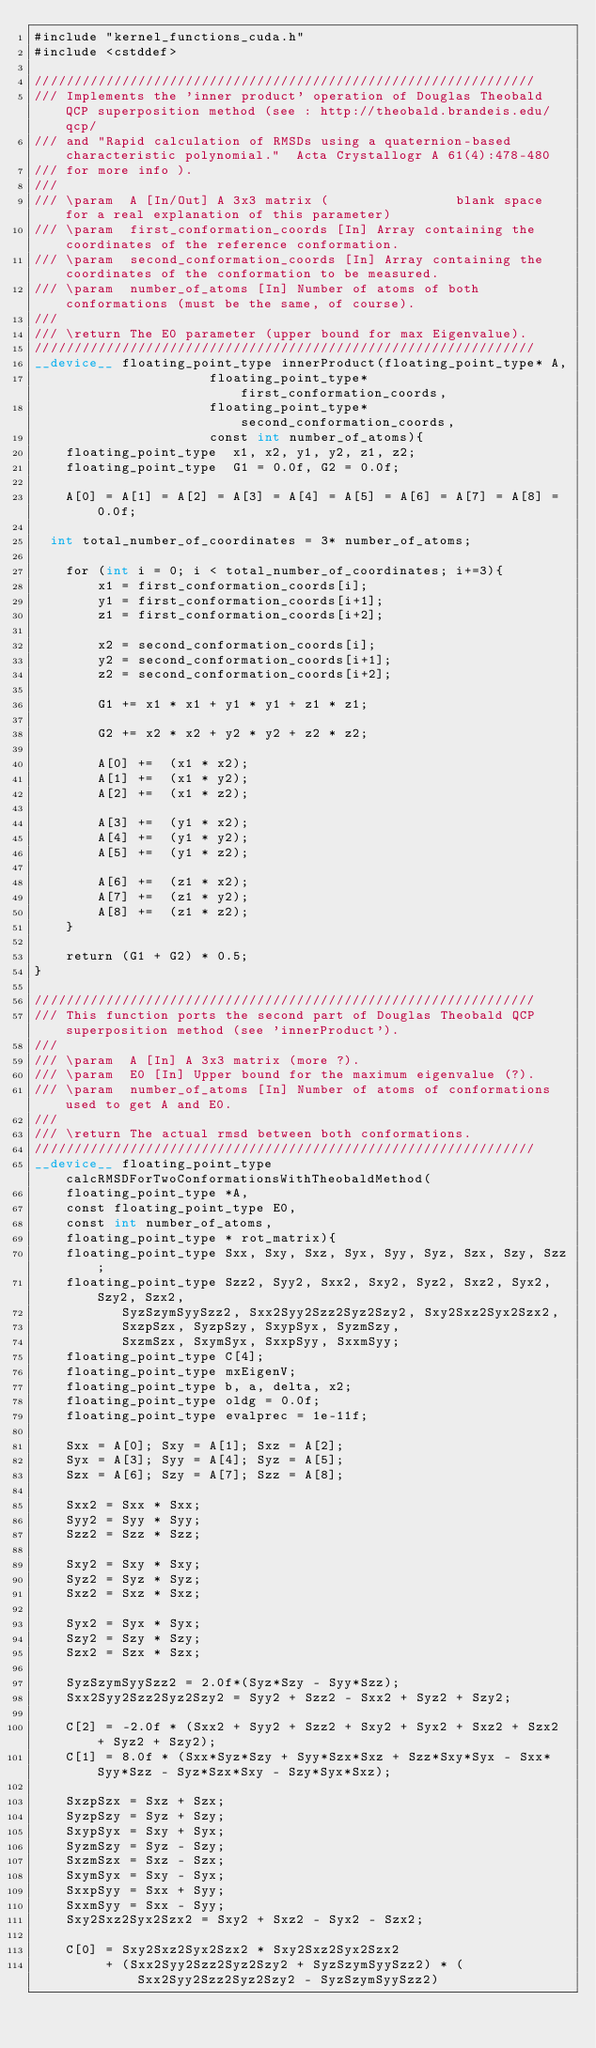<code> <loc_0><loc_0><loc_500><loc_500><_Cuda_>#include "kernel_functions_cuda.h"
#include <cstddef>

///////////////////////////////////////////////////////////////
/// Implements the 'inner product' operation of Douglas Theobald QCP superposition method (see : http://theobald.brandeis.edu/qcp/
/// and "Rapid calculation of RMSDs using a quaternion-based characteristic polynomial."  Acta Crystallogr A 61(4):478-480
/// for more info ).
///
/// \param 	A [In/Out] A 3x3 matrix (                blank space for a real explanation of this parameter)
/// \param 	first_conformation_coords [In] Array containing the coordinates of the reference conformation.
/// \param 	second_conformation_coords [In] Array containing the coordinates of the conformation to be measured.
/// \param 	number_of_atoms [In] Number of atoms of both conformations (must be the same, of course).
///
/// \return The E0 parameter (upper bound for max Eigenvalue).
///////////////////////////////////////////////////////////////
__device__ floating_point_type innerProduct(floating_point_type* A, 
											floating_point_type* first_conformation_coords, 
											floating_point_type* second_conformation_coords, 
											const int number_of_atoms){
    floating_point_type  x1, x2, y1, y2, z1, z2;
    floating_point_type  G1 = 0.0f, G2 = 0.0f;

    A[0] = A[1] = A[2] = A[3] = A[4] = A[5] = A[6] = A[7] = A[8] = 0.0f;

	int total_number_of_coordinates = 3* number_of_atoms;
    
    for (int i = 0; i < total_number_of_coordinates; i+=3){
        x1 = first_conformation_coords[i];
        y1 = first_conformation_coords[i+1];
        z1 = first_conformation_coords[i+2];

        x2 = second_conformation_coords[i];
        y2 = second_conformation_coords[i+1];
        z2 = second_conformation_coords[i+2];

        G1 += x1 * x1 + y1 * y1 + z1 * z1;

        G2 += x2 * x2 + y2 * y2 + z2 * z2;

        A[0] +=  (x1 * x2);
        A[1] +=  (x1 * y2);
        A[2] +=  (x1 * z2);

        A[3] +=  (y1 * x2);
        A[4] +=  (y1 * y2);
        A[5] +=  (y1 * z2);

        A[6] +=  (z1 * x2);
        A[7] +=  (z1 * y2);
        A[8] +=  (z1 * z2);  
    }

    return (G1 + G2) * 0.5;
}

///////////////////////////////////////////////////////////////
///	This function ports the second part of Douglas Theobald QCP superposition method (see 'innerProduct').
///
/// \param 	A [In] A 3x3 matrix (more ?).
/// \param 	E0 [In] Upper bound for the maximum eigenvalue (?).
/// \param 	number_of_atoms [In] Number of atoms of conformations used to get A and E0.
///
/// \return The actual rmsd between both conformations.
///////////////////////////////////////////////////////////////
__device__ floating_point_type calcRMSDForTwoConformationsWithTheobaldMethod(
		floating_point_type *A,
		const floating_point_type E0,
		const int number_of_atoms,
		floating_point_type * rot_matrix){
    floating_point_type Sxx, Sxy, Sxz, Syx, Syy, Syz, Szx, Szy, Szz;
    floating_point_type Szz2, Syy2, Sxx2, Sxy2, Syz2, Sxz2, Syx2, Szy2, Szx2,
           SyzSzymSyySzz2, Sxx2Syy2Szz2Syz2Szy2, Sxy2Sxz2Syx2Szx2,
           SxzpSzx, SyzpSzy, SxypSyx, SyzmSzy,
           SxzmSzx, SxymSyx, SxxpSyy, SxxmSyy;
    floating_point_type C[4];
    floating_point_type mxEigenV; 
    floating_point_type b, a, delta, x2;
    floating_point_type oldg = 0.0f;
    floating_point_type evalprec = 1e-11f;

    Sxx = A[0]; Sxy = A[1]; Sxz = A[2];
    Syx = A[3]; Syy = A[4]; Syz = A[5];
    Szx = A[6]; Szy = A[7]; Szz = A[8];

    Sxx2 = Sxx * Sxx;
    Syy2 = Syy * Syy;
    Szz2 = Szz * Szz;

    Sxy2 = Sxy * Sxy;
    Syz2 = Syz * Syz;
    Sxz2 = Sxz * Sxz;

    Syx2 = Syx * Syx;
    Szy2 = Szy * Szy;
    Szx2 = Szx * Szx;

    SyzSzymSyySzz2 = 2.0f*(Syz*Szy - Syy*Szz);
    Sxx2Syy2Szz2Syz2Szy2 = Syy2 + Szz2 - Sxx2 + Syz2 + Szy2;

    C[2] = -2.0f * (Sxx2 + Syy2 + Szz2 + Sxy2 + Syx2 + Sxz2 + Szx2 + Syz2 + Szy2);
    C[1] = 8.0f * (Sxx*Syz*Szy + Syy*Szx*Sxz + Szz*Sxy*Syx - Sxx*Syy*Szz - Syz*Szx*Sxy - Szy*Syx*Sxz);

    SxzpSzx = Sxz + Szx;
    SyzpSzy = Syz + Szy;
    SxypSyx = Sxy + Syx;
    SyzmSzy = Syz - Szy;
    SxzmSzx = Sxz - Szx;
    SxymSyx = Sxy - Syx;
    SxxpSyy = Sxx + Syy;
    SxxmSyy = Sxx - Syy;
    Sxy2Sxz2Syx2Szx2 = Sxy2 + Sxz2 - Syx2 - Szx2;

    C[0] = Sxy2Sxz2Syx2Szx2 * Sxy2Sxz2Syx2Szx2
         + (Sxx2Syy2Szz2Syz2Szy2 + SyzSzymSyySzz2) * (Sxx2Syy2Szz2Syz2Szy2 - SyzSzymSyySzz2)</code> 